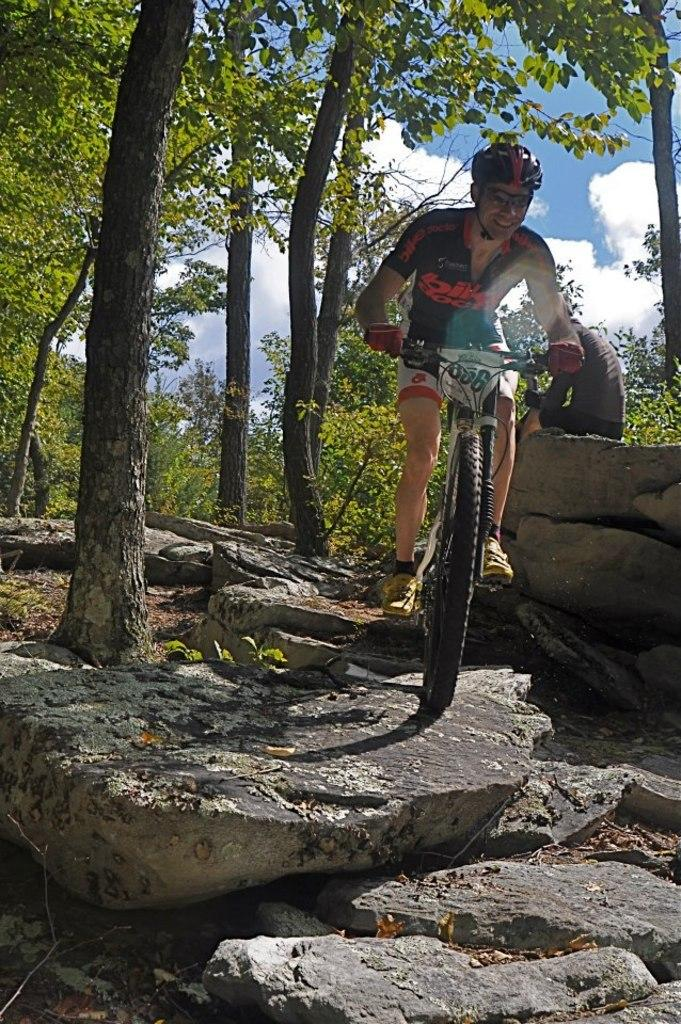What activity is the person in the image engaged in? There is a person riding a bicycle in the image. Can you describe the other person in the image? There is a person sitting on a rock in the image. What type of natural features are present in the image? There are rocks and trees in the image. What can be seen in the background of the image? The sky is visible in the background of the image. What degree does the person playing the guitar have in the image? There is no person playing the guitar in the image; it only features a person riding a bicycle and another person sitting on a rock. 